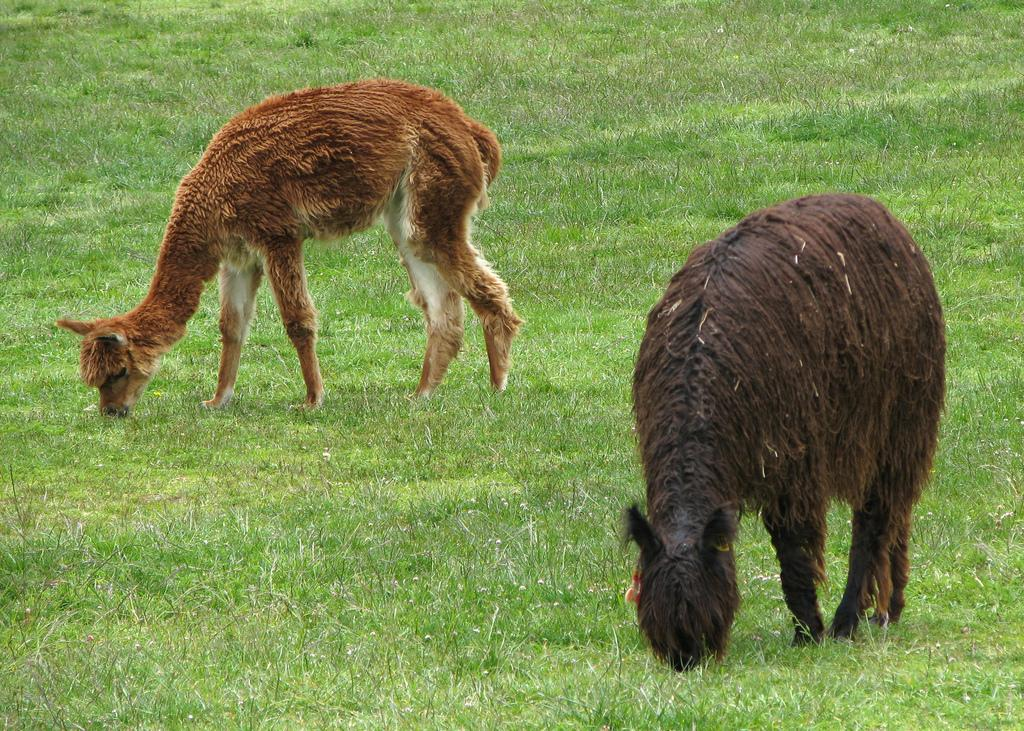How many animals are present in the image? There are two animals in the image. What colors can be seen on the animals? The animals are in brown, cream, and black colors. What type of vegetation is visible in the image? There is green color grass in the image. What shape is the substance on the ground in the image? There is no substance on the ground in the image; it only shows two animals and green grass. 